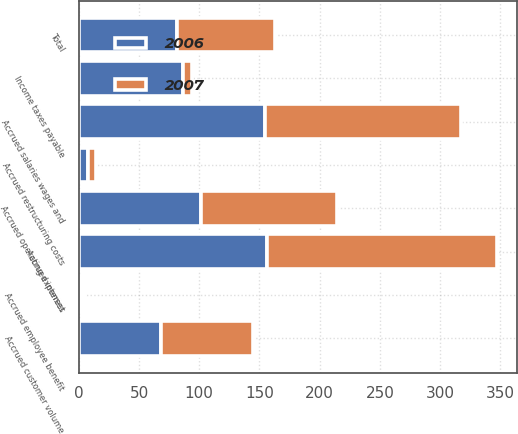Convert chart to OTSL. <chart><loc_0><loc_0><loc_500><loc_500><stacked_bar_chart><ecel><fcel>Accrued salaries wages and<fcel>Accrued operating expenses<fcel>Income taxes payable<fcel>Accrued customer volume<fcel>Accrued interest<fcel>Accrued employee benefit<fcel>Accrued restructuring costs<fcel>Total<nl><fcel>2007<fcel>163.2<fcel>112.8<fcel>8<fcel>76.4<fcel>190.5<fcel>2.7<fcel>6.9<fcel>81.3<nl><fcel>2006<fcel>154.3<fcel>101.5<fcel>86.2<fcel>67.9<fcel>156.4<fcel>2.3<fcel>7.6<fcel>81.3<nl></chart> 